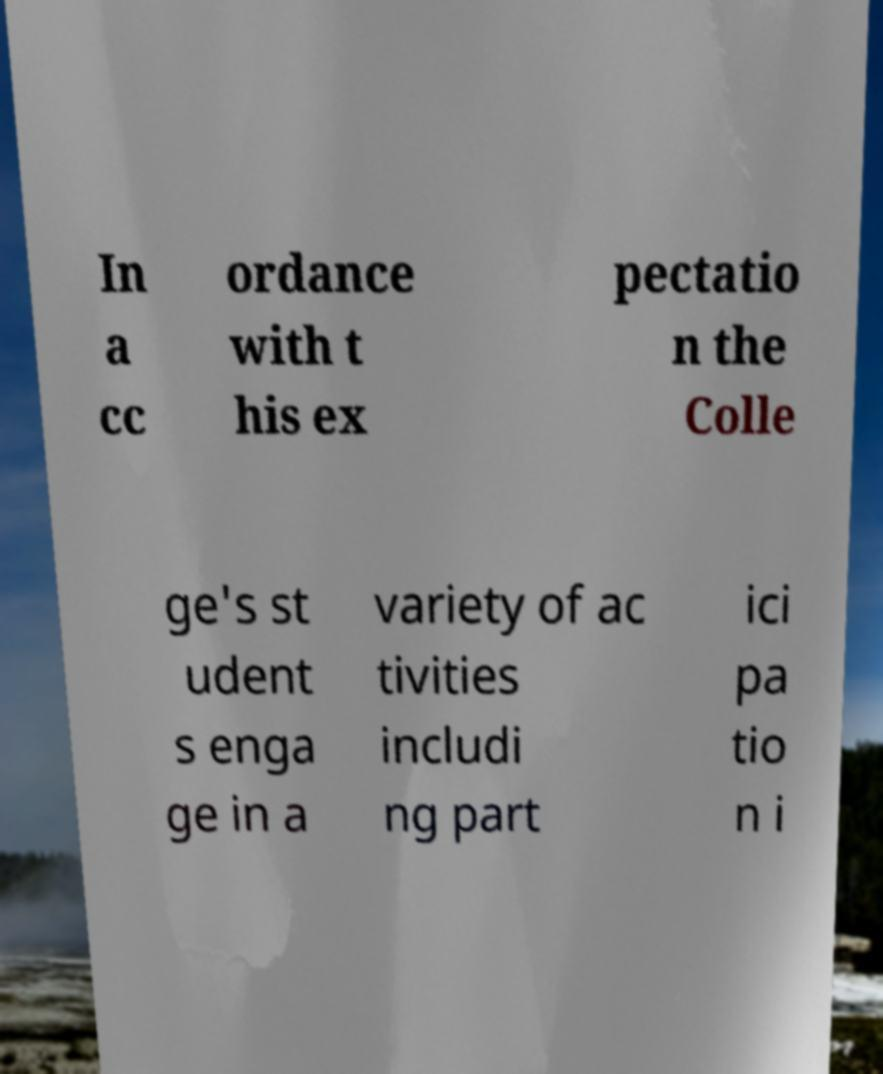Could you extract and type out the text from this image? In a cc ordance with t his ex pectatio n the Colle ge's st udent s enga ge in a variety of ac tivities includi ng part ici pa tio n i 